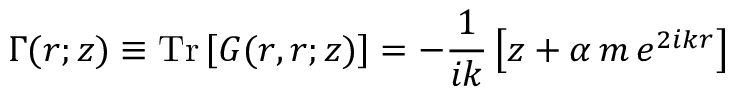Convert formula to latex. <formula><loc_0><loc_0><loc_500><loc_500>\Gamma ( r ; z ) \equiv T r \left [ G ( r , r ; z ) \right ] = - \frac { 1 } { i k } \left [ z + \alpha \, m \, e ^ { 2 i k r } \right ]</formula> 